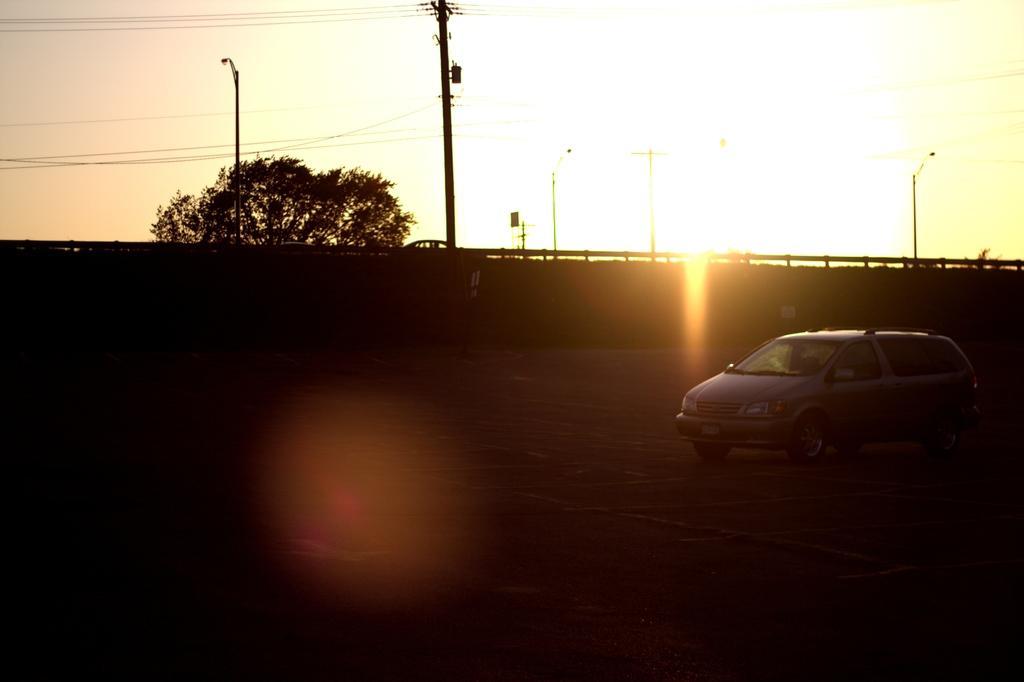How would you summarize this image in a sentence or two? In this picture I can see a vehicle on the road, side there is a wall and also the tree. 